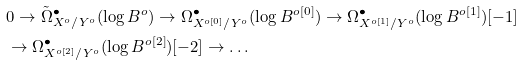Convert formula to latex. <formula><loc_0><loc_0><loc_500><loc_500>& 0 \to \tilde { \Omega } ^ { \bullet } _ { X ^ { o } / Y ^ { o } } ( \log B ^ { o } ) \to \Omega ^ { \bullet } _ { X ^ { o [ 0 ] } / Y ^ { o } } ( \log B ^ { o [ 0 ] } ) \to \Omega ^ { \bullet } _ { X ^ { o [ 1 ] } / Y ^ { o } } ( \log B ^ { o [ 1 ] } ) [ - 1 ] \\ & \to \Omega ^ { \bullet } _ { X ^ { o [ 2 ] } / Y ^ { o } } ( \log B ^ { o [ 2 ] } ) [ - 2 ] \to \dots</formula> 